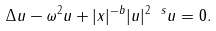Convert formula to latex. <formula><loc_0><loc_0><loc_500><loc_500>\Delta u - \omega ^ { 2 } u + | x | ^ { - b } | u | ^ { 2 \ s } u = 0 .</formula> 